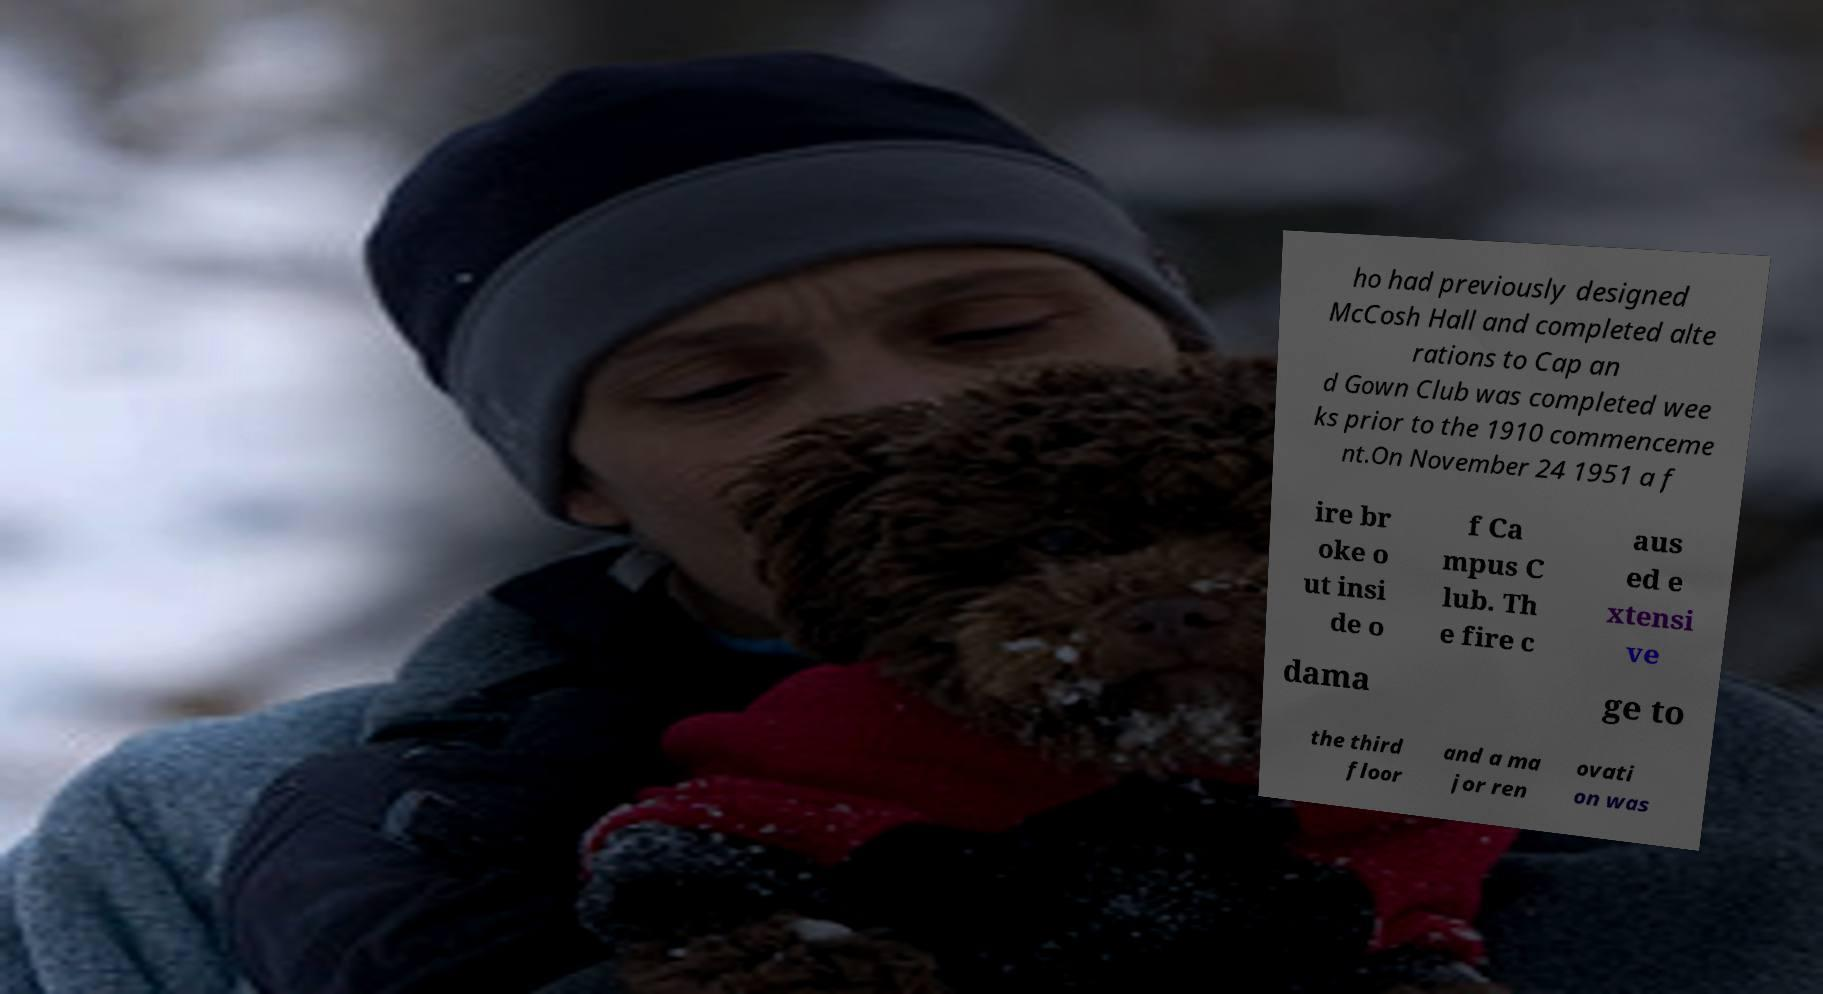What messages or text are displayed in this image? I need them in a readable, typed format. ho had previously designed McCosh Hall and completed alte rations to Cap an d Gown Club was completed wee ks prior to the 1910 commenceme nt.On November 24 1951 a f ire br oke o ut insi de o f Ca mpus C lub. Th e fire c aus ed e xtensi ve dama ge to the third floor and a ma jor ren ovati on was 